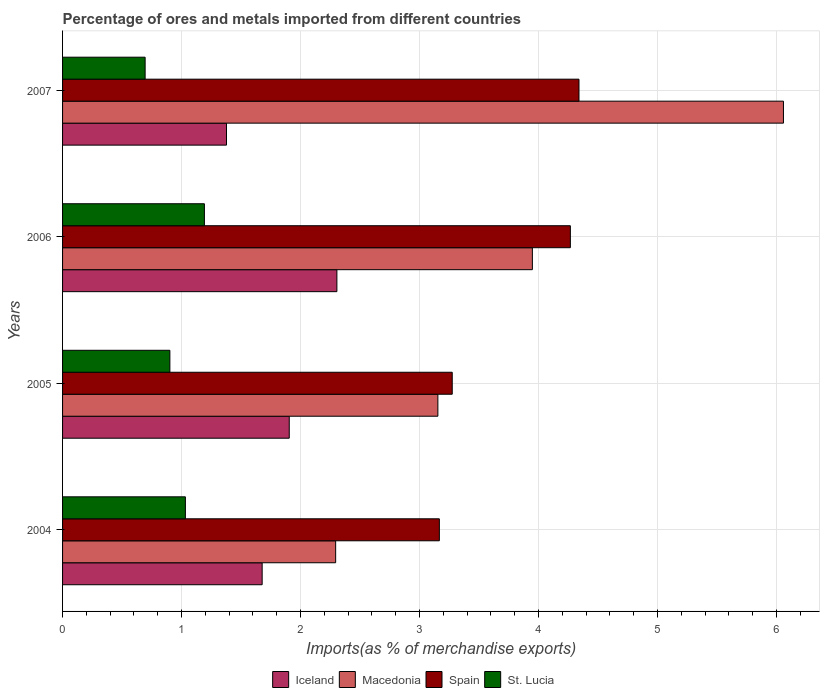How many different coloured bars are there?
Provide a short and direct response. 4. How many groups of bars are there?
Ensure brevity in your answer.  4. Are the number of bars per tick equal to the number of legend labels?
Provide a succinct answer. Yes. How many bars are there on the 2nd tick from the top?
Your response must be concise. 4. In how many cases, is the number of bars for a given year not equal to the number of legend labels?
Your answer should be very brief. 0. What is the percentage of imports to different countries in Macedonia in 2007?
Give a very brief answer. 6.06. Across all years, what is the maximum percentage of imports to different countries in St. Lucia?
Your answer should be very brief. 1.19. Across all years, what is the minimum percentage of imports to different countries in St. Lucia?
Your response must be concise. 0.69. In which year was the percentage of imports to different countries in Macedonia maximum?
Provide a succinct answer. 2007. What is the total percentage of imports to different countries in St. Lucia in the graph?
Provide a succinct answer. 3.82. What is the difference between the percentage of imports to different countries in St. Lucia in 2004 and that in 2006?
Provide a short and direct response. -0.16. What is the difference between the percentage of imports to different countries in Spain in 2004 and the percentage of imports to different countries in St. Lucia in 2006?
Your answer should be compact. 1.97. What is the average percentage of imports to different countries in Macedonia per year?
Offer a very short reply. 3.86. In the year 2004, what is the difference between the percentage of imports to different countries in Macedonia and percentage of imports to different countries in Iceland?
Offer a terse response. 0.62. What is the ratio of the percentage of imports to different countries in Macedonia in 2004 to that in 2005?
Your answer should be compact. 0.73. Is the percentage of imports to different countries in Iceland in 2004 less than that in 2005?
Your answer should be very brief. Yes. What is the difference between the highest and the second highest percentage of imports to different countries in Iceland?
Keep it short and to the point. 0.4. What is the difference between the highest and the lowest percentage of imports to different countries in Macedonia?
Offer a very short reply. 3.76. In how many years, is the percentage of imports to different countries in Iceland greater than the average percentage of imports to different countries in Iceland taken over all years?
Offer a very short reply. 2. Is the sum of the percentage of imports to different countries in Macedonia in 2005 and 2007 greater than the maximum percentage of imports to different countries in Spain across all years?
Ensure brevity in your answer.  Yes. What does the 3rd bar from the top in 2004 represents?
Give a very brief answer. Macedonia. Is it the case that in every year, the sum of the percentage of imports to different countries in Iceland and percentage of imports to different countries in Macedonia is greater than the percentage of imports to different countries in Spain?
Ensure brevity in your answer.  Yes. Are all the bars in the graph horizontal?
Your answer should be compact. Yes. Does the graph contain any zero values?
Provide a short and direct response. No. Does the graph contain grids?
Offer a very short reply. Yes. How many legend labels are there?
Keep it short and to the point. 4. What is the title of the graph?
Keep it short and to the point. Percentage of ores and metals imported from different countries. What is the label or title of the X-axis?
Give a very brief answer. Imports(as % of merchandise exports). What is the Imports(as % of merchandise exports) in Iceland in 2004?
Provide a succinct answer. 1.68. What is the Imports(as % of merchandise exports) in Macedonia in 2004?
Ensure brevity in your answer.  2.3. What is the Imports(as % of merchandise exports) in Spain in 2004?
Offer a terse response. 3.17. What is the Imports(as % of merchandise exports) of St. Lucia in 2004?
Provide a short and direct response. 1.03. What is the Imports(as % of merchandise exports) of Iceland in 2005?
Your answer should be compact. 1.91. What is the Imports(as % of merchandise exports) in Macedonia in 2005?
Offer a very short reply. 3.15. What is the Imports(as % of merchandise exports) of Spain in 2005?
Provide a short and direct response. 3.28. What is the Imports(as % of merchandise exports) of St. Lucia in 2005?
Your answer should be very brief. 0.9. What is the Imports(as % of merchandise exports) of Iceland in 2006?
Your answer should be compact. 2.31. What is the Imports(as % of merchandise exports) of Macedonia in 2006?
Provide a short and direct response. 3.95. What is the Imports(as % of merchandise exports) in Spain in 2006?
Give a very brief answer. 4.27. What is the Imports(as % of merchandise exports) of St. Lucia in 2006?
Give a very brief answer. 1.19. What is the Imports(as % of merchandise exports) in Iceland in 2007?
Your response must be concise. 1.38. What is the Imports(as % of merchandise exports) of Macedonia in 2007?
Offer a terse response. 6.06. What is the Imports(as % of merchandise exports) in Spain in 2007?
Your answer should be compact. 4.34. What is the Imports(as % of merchandise exports) of St. Lucia in 2007?
Provide a succinct answer. 0.69. Across all years, what is the maximum Imports(as % of merchandise exports) in Iceland?
Provide a short and direct response. 2.31. Across all years, what is the maximum Imports(as % of merchandise exports) of Macedonia?
Your response must be concise. 6.06. Across all years, what is the maximum Imports(as % of merchandise exports) of Spain?
Give a very brief answer. 4.34. Across all years, what is the maximum Imports(as % of merchandise exports) of St. Lucia?
Offer a terse response. 1.19. Across all years, what is the minimum Imports(as % of merchandise exports) of Iceland?
Keep it short and to the point. 1.38. Across all years, what is the minimum Imports(as % of merchandise exports) in Macedonia?
Your answer should be very brief. 2.3. Across all years, what is the minimum Imports(as % of merchandise exports) in Spain?
Your answer should be very brief. 3.17. Across all years, what is the minimum Imports(as % of merchandise exports) of St. Lucia?
Provide a short and direct response. 0.69. What is the total Imports(as % of merchandise exports) in Iceland in the graph?
Your answer should be very brief. 7.27. What is the total Imports(as % of merchandise exports) of Macedonia in the graph?
Offer a terse response. 15.46. What is the total Imports(as % of merchandise exports) in Spain in the graph?
Provide a succinct answer. 15.05. What is the total Imports(as % of merchandise exports) in St. Lucia in the graph?
Your answer should be very brief. 3.82. What is the difference between the Imports(as % of merchandise exports) in Iceland in 2004 and that in 2005?
Make the answer very short. -0.23. What is the difference between the Imports(as % of merchandise exports) of Macedonia in 2004 and that in 2005?
Make the answer very short. -0.86. What is the difference between the Imports(as % of merchandise exports) of Spain in 2004 and that in 2005?
Your answer should be very brief. -0.11. What is the difference between the Imports(as % of merchandise exports) in St. Lucia in 2004 and that in 2005?
Provide a short and direct response. 0.13. What is the difference between the Imports(as % of merchandise exports) in Iceland in 2004 and that in 2006?
Give a very brief answer. -0.63. What is the difference between the Imports(as % of merchandise exports) of Macedonia in 2004 and that in 2006?
Your answer should be very brief. -1.65. What is the difference between the Imports(as % of merchandise exports) in Spain in 2004 and that in 2006?
Your answer should be compact. -1.1. What is the difference between the Imports(as % of merchandise exports) of St. Lucia in 2004 and that in 2006?
Provide a succinct answer. -0.16. What is the difference between the Imports(as % of merchandise exports) of Iceland in 2004 and that in 2007?
Ensure brevity in your answer.  0.3. What is the difference between the Imports(as % of merchandise exports) in Macedonia in 2004 and that in 2007?
Offer a terse response. -3.76. What is the difference between the Imports(as % of merchandise exports) of Spain in 2004 and that in 2007?
Provide a succinct answer. -1.17. What is the difference between the Imports(as % of merchandise exports) in St. Lucia in 2004 and that in 2007?
Make the answer very short. 0.34. What is the difference between the Imports(as % of merchandise exports) in Iceland in 2005 and that in 2006?
Give a very brief answer. -0.4. What is the difference between the Imports(as % of merchandise exports) in Macedonia in 2005 and that in 2006?
Provide a short and direct response. -0.79. What is the difference between the Imports(as % of merchandise exports) of Spain in 2005 and that in 2006?
Your response must be concise. -0.99. What is the difference between the Imports(as % of merchandise exports) of St. Lucia in 2005 and that in 2006?
Keep it short and to the point. -0.29. What is the difference between the Imports(as % of merchandise exports) in Iceland in 2005 and that in 2007?
Offer a very short reply. 0.53. What is the difference between the Imports(as % of merchandise exports) in Macedonia in 2005 and that in 2007?
Keep it short and to the point. -2.9. What is the difference between the Imports(as % of merchandise exports) in Spain in 2005 and that in 2007?
Offer a very short reply. -1.07. What is the difference between the Imports(as % of merchandise exports) of St. Lucia in 2005 and that in 2007?
Provide a short and direct response. 0.21. What is the difference between the Imports(as % of merchandise exports) of Iceland in 2006 and that in 2007?
Provide a short and direct response. 0.93. What is the difference between the Imports(as % of merchandise exports) of Macedonia in 2006 and that in 2007?
Provide a succinct answer. -2.11. What is the difference between the Imports(as % of merchandise exports) of Spain in 2006 and that in 2007?
Give a very brief answer. -0.07. What is the difference between the Imports(as % of merchandise exports) in St. Lucia in 2006 and that in 2007?
Provide a short and direct response. 0.5. What is the difference between the Imports(as % of merchandise exports) in Iceland in 2004 and the Imports(as % of merchandise exports) in Macedonia in 2005?
Your response must be concise. -1.48. What is the difference between the Imports(as % of merchandise exports) in Iceland in 2004 and the Imports(as % of merchandise exports) in Spain in 2005?
Keep it short and to the point. -1.6. What is the difference between the Imports(as % of merchandise exports) in Iceland in 2004 and the Imports(as % of merchandise exports) in St. Lucia in 2005?
Keep it short and to the point. 0.78. What is the difference between the Imports(as % of merchandise exports) of Macedonia in 2004 and the Imports(as % of merchandise exports) of Spain in 2005?
Your response must be concise. -0.98. What is the difference between the Imports(as % of merchandise exports) of Macedonia in 2004 and the Imports(as % of merchandise exports) of St. Lucia in 2005?
Make the answer very short. 1.39. What is the difference between the Imports(as % of merchandise exports) in Spain in 2004 and the Imports(as % of merchandise exports) in St. Lucia in 2005?
Your answer should be compact. 2.27. What is the difference between the Imports(as % of merchandise exports) of Iceland in 2004 and the Imports(as % of merchandise exports) of Macedonia in 2006?
Offer a terse response. -2.27. What is the difference between the Imports(as % of merchandise exports) in Iceland in 2004 and the Imports(as % of merchandise exports) in Spain in 2006?
Ensure brevity in your answer.  -2.59. What is the difference between the Imports(as % of merchandise exports) in Iceland in 2004 and the Imports(as % of merchandise exports) in St. Lucia in 2006?
Offer a terse response. 0.49. What is the difference between the Imports(as % of merchandise exports) in Macedonia in 2004 and the Imports(as % of merchandise exports) in Spain in 2006?
Provide a short and direct response. -1.97. What is the difference between the Imports(as % of merchandise exports) in Macedonia in 2004 and the Imports(as % of merchandise exports) in St. Lucia in 2006?
Offer a terse response. 1.1. What is the difference between the Imports(as % of merchandise exports) of Spain in 2004 and the Imports(as % of merchandise exports) of St. Lucia in 2006?
Your answer should be very brief. 1.97. What is the difference between the Imports(as % of merchandise exports) in Iceland in 2004 and the Imports(as % of merchandise exports) in Macedonia in 2007?
Ensure brevity in your answer.  -4.38. What is the difference between the Imports(as % of merchandise exports) of Iceland in 2004 and the Imports(as % of merchandise exports) of Spain in 2007?
Ensure brevity in your answer.  -2.66. What is the difference between the Imports(as % of merchandise exports) of Iceland in 2004 and the Imports(as % of merchandise exports) of St. Lucia in 2007?
Give a very brief answer. 0.98. What is the difference between the Imports(as % of merchandise exports) in Macedonia in 2004 and the Imports(as % of merchandise exports) in Spain in 2007?
Offer a terse response. -2.05. What is the difference between the Imports(as % of merchandise exports) in Macedonia in 2004 and the Imports(as % of merchandise exports) in St. Lucia in 2007?
Make the answer very short. 1.6. What is the difference between the Imports(as % of merchandise exports) in Spain in 2004 and the Imports(as % of merchandise exports) in St. Lucia in 2007?
Your answer should be very brief. 2.47. What is the difference between the Imports(as % of merchandise exports) of Iceland in 2005 and the Imports(as % of merchandise exports) of Macedonia in 2006?
Give a very brief answer. -2.04. What is the difference between the Imports(as % of merchandise exports) in Iceland in 2005 and the Imports(as % of merchandise exports) in Spain in 2006?
Offer a terse response. -2.36. What is the difference between the Imports(as % of merchandise exports) of Iceland in 2005 and the Imports(as % of merchandise exports) of St. Lucia in 2006?
Offer a terse response. 0.71. What is the difference between the Imports(as % of merchandise exports) of Macedonia in 2005 and the Imports(as % of merchandise exports) of Spain in 2006?
Offer a terse response. -1.11. What is the difference between the Imports(as % of merchandise exports) of Macedonia in 2005 and the Imports(as % of merchandise exports) of St. Lucia in 2006?
Your answer should be very brief. 1.96. What is the difference between the Imports(as % of merchandise exports) of Spain in 2005 and the Imports(as % of merchandise exports) of St. Lucia in 2006?
Provide a succinct answer. 2.08. What is the difference between the Imports(as % of merchandise exports) in Iceland in 2005 and the Imports(as % of merchandise exports) in Macedonia in 2007?
Give a very brief answer. -4.15. What is the difference between the Imports(as % of merchandise exports) in Iceland in 2005 and the Imports(as % of merchandise exports) in Spain in 2007?
Your response must be concise. -2.44. What is the difference between the Imports(as % of merchandise exports) in Iceland in 2005 and the Imports(as % of merchandise exports) in St. Lucia in 2007?
Keep it short and to the point. 1.21. What is the difference between the Imports(as % of merchandise exports) in Macedonia in 2005 and the Imports(as % of merchandise exports) in Spain in 2007?
Offer a terse response. -1.19. What is the difference between the Imports(as % of merchandise exports) in Macedonia in 2005 and the Imports(as % of merchandise exports) in St. Lucia in 2007?
Your response must be concise. 2.46. What is the difference between the Imports(as % of merchandise exports) in Spain in 2005 and the Imports(as % of merchandise exports) in St. Lucia in 2007?
Provide a succinct answer. 2.58. What is the difference between the Imports(as % of merchandise exports) in Iceland in 2006 and the Imports(as % of merchandise exports) in Macedonia in 2007?
Your response must be concise. -3.75. What is the difference between the Imports(as % of merchandise exports) of Iceland in 2006 and the Imports(as % of merchandise exports) of Spain in 2007?
Give a very brief answer. -2.03. What is the difference between the Imports(as % of merchandise exports) of Iceland in 2006 and the Imports(as % of merchandise exports) of St. Lucia in 2007?
Make the answer very short. 1.61. What is the difference between the Imports(as % of merchandise exports) in Macedonia in 2006 and the Imports(as % of merchandise exports) in Spain in 2007?
Keep it short and to the point. -0.39. What is the difference between the Imports(as % of merchandise exports) of Macedonia in 2006 and the Imports(as % of merchandise exports) of St. Lucia in 2007?
Make the answer very short. 3.25. What is the difference between the Imports(as % of merchandise exports) in Spain in 2006 and the Imports(as % of merchandise exports) in St. Lucia in 2007?
Offer a very short reply. 3.57. What is the average Imports(as % of merchandise exports) in Iceland per year?
Provide a short and direct response. 1.82. What is the average Imports(as % of merchandise exports) of Macedonia per year?
Ensure brevity in your answer.  3.86. What is the average Imports(as % of merchandise exports) in Spain per year?
Provide a short and direct response. 3.76. What is the average Imports(as % of merchandise exports) in St. Lucia per year?
Provide a short and direct response. 0.96. In the year 2004, what is the difference between the Imports(as % of merchandise exports) of Iceland and Imports(as % of merchandise exports) of Macedonia?
Offer a terse response. -0.62. In the year 2004, what is the difference between the Imports(as % of merchandise exports) of Iceland and Imports(as % of merchandise exports) of Spain?
Your answer should be very brief. -1.49. In the year 2004, what is the difference between the Imports(as % of merchandise exports) in Iceland and Imports(as % of merchandise exports) in St. Lucia?
Keep it short and to the point. 0.65. In the year 2004, what is the difference between the Imports(as % of merchandise exports) of Macedonia and Imports(as % of merchandise exports) of Spain?
Make the answer very short. -0.87. In the year 2004, what is the difference between the Imports(as % of merchandise exports) in Macedonia and Imports(as % of merchandise exports) in St. Lucia?
Give a very brief answer. 1.26. In the year 2004, what is the difference between the Imports(as % of merchandise exports) in Spain and Imports(as % of merchandise exports) in St. Lucia?
Ensure brevity in your answer.  2.13. In the year 2005, what is the difference between the Imports(as % of merchandise exports) in Iceland and Imports(as % of merchandise exports) in Macedonia?
Your answer should be very brief. -1.25. In the year 2005, what is the difference between the Imports(as % of merchandise exports) in Iceland and Imports(as % of merchandise exports) in Spain?
Ensure brevity in your answer.  -1.37. In the year 2005, what is the difference between the Imports(as % of merchandise exports) in Iceland and Imports(as % of merchandise exports) in St. Lucia?
Provide a succinct answer. 1. In the year 2005, what is the difference between the Imports(as % of merchandise exports) in Macedonia and Imports(as % of merchandise exports) in Spain?
Your response must be concise. -0.12. In the year 2005, what is the difference between the Imports(as % of merchandise exports) of Macedonia and Imports(as % of merchandise exports) of St. Lucia?
Your answer should be compact. 2.25. In the year 2005, what is the difference between the Imports(as % of merchandise exports) in Spain and Imports(as % of merchandise exports) in St. Lucia?
Provide a short and direct response. 2.37. In the year 2006, what is the difference between the Imports(as % of merchandise exports) in Iceland and Imports(as % of merchandise exports) in Macedonia?
Provide a short and direct response. -1.64. In the year 2006, what is the difference between the Imports(as % of merchandise exports) of Iceland and Imports(as % of merchandise exports) of Spain?
Your answer should be very brief. -1.96. In the year 2006, what is the difference between the Imports(as % of merchandise exports) in Iceland and Imports(as % of merchandise exports) in St. Lucia?
Offer a terse response. 1.11. In the year 2006, what is the difference between the Imports(as % of merchandise exports) in Macedonia and Imports(as % of merchandise exports) in Spain?
Provide a short and direct response. -0.32. In the year 2006, what is the difference between the Imports(as % of merchandise exports) in Macedonia and Imports(as % of merchandise exports) in St. Lucia?
Provide a short and direct response. 2.76. In the year 2006, what is the difference between the Imports(as % of merchandise exports) of Spain and Imports(as % of merchandise exports) of St. Lucia?
Ensure brevity in your answer.  3.08. In the year 2007, what is the difference between the Imports(as % of merchandise exports) of Iceland and Imports(as % of merchandise exports) of Macedonia?
Offer a very short reply. -4.68. In the year 2007, what is the difference between the Imports(as % of merchandise exports) in Iceland and Imports(as % of merchandise exports) in Spain?
Offer a terse response. -2.96. In the year 2007, what is the difference between the Imports(as % of merchandise exports) of Iceland and Imports(as % of merchandise exports) of St. Lucia?
Offer a very short reply. 0.68. In the year 2007, what is the difference between the Imports(as % of merchandise exports) of Macedonia and Imports(as % of merchandise exports) of Spain?
Ensure brevity in your answer.  1.72. In the year 2007, what is the difference between the Imports(as % of merchandise exports) in Macedonia and Imports(as % of merchandise exports) in St. Lucia?
Provide a short and direct response. 5.37. In the year 2007, what is the difference between the Imports(as % of merchandise exports) in Spain and Imports(as % of merchandise exports) in St. Lucia?
Keep it short and to the point. 3.65. What is the ratio of the Imports(as % of merchandise exports) in Iceland in 2004 to that in 2005?
Offer a terse response. 0.88. What is the ratio of the Imports(as % of merchandise exports) of Macedonia in 2004 to that in 2005?
Your response must be concise. 0.73. What is the ratio of the Imports(as % of merchandise exports) in Spain in 2004 to that in 2005?
Offer a terse response. 0.97. What is the ratio of the Imports(as % of merchandise exports) in St. Lucia in 2004 to that in 2005?
Give a very brief answer. 1.14. What is the ratio of the Imports(as % of merchandise exports) in Iceland in 2004 to that in 2006?
Give a very brief answer. 0.73. What is the ratio of the Imports(as % of merchandise exports) of Macedonia in 2004 to that in 2006?
Ensure brevity in your answer.  0.58. What is the ratio of the Imports(as % of merchandise exports) in Spain in 2004 to that in 2006?
Give a very brief answer. 0.74. What is the ratio of the Imports(as % of merchandise exports) in St. Lucia in 2004 to that in 2006?
Offer a very short reply. 0.87. What is the ratio of the Imports(as % of merchandise exports) in Iceland in 2004 to that in 2007?
Keep it short and to the point. 1.22. What is the ratio of the Imports(as % of merchandise exports) of Macedonia in 2004 to that in 2007?
Your answer should be very brief. 0.38. What is the ratio of the Imports(as % of merchandise exports) in Spain in 2004 to that in 2007?
Provide a succinct answer. 0.73. What is the ratio of the Imports(as % of merchandise exports) of St. Lucia in 2004 to that in 2007?
Your answer should be compact. 1.49. What is the ratio of the Imports(as % of merchandise exports) in Iceland in 2005 to that in 2006?
Provide a short and direct response. 0.83. What is the ratio of the Imports(as % of merchandise exports) of Macedonia in 2005 to that in 2006?
Offer a very short reply. 0.8. What is the ratio of the Imports(as % of merchandise exports) of Spain in 2005 to that in 2006?
Ensure brevity in your answer.  0.77. What is the ratio of the Imports(as % of merchandise exports) in St. Lucia in 2005 to that in 2006?
Your answer should be very brief. 0.76. What is the ratio of the Imports(as % of merchandise exports) in Iceland in 2005 to that in 2007?
Your answer should be very brief. 1.38. What is the ratio of the Imports(as % of merchandise exports) of Macedonia in 2005 to that in 2007?
Your answer should be compact. 0.52. What is the ratio of the Imports(as % of merchandise exports) in Spain in 2005 to that in 2007?
Make the answer very short. 0.75. What is the ratio of the Imports(as % of merchandise exports) of St. Lucia in 2005 to that in 2007?
Ensure brevity in your answer.  1.3. What is the ratio of the Imports(as % of merchandise exports) in Iceland in 2006 to that in 2007?
Give a very brief answer. 1.67. What is the ratio of the Imports(as % of merchandise exports) in Macedonia in 2006 to that in 2007?
Give a very brief answer. 0.65. What is the ratio of the Imports(as % of merchandise exports) of Spain in 2006 to that in 2007?
Your answer should be compact. 0.98. What is the ratio of the Imports(as % of merchandise exports) of St. Lucia in 2006 to that in 2007?
Ensure brevity in your answer.  1.72. What is the difference between the highest and the second highest Imports(as % of merchandise exports) of Iceland?
Make the answer very short. 0.4. What is the difference between the highest and the second highest Imports(as % of merchandise exports) of Macedonia?
Your answer should be compact. 2.11. What is the difference between the highest and the second highest Imports(as % of merchandise exports) in Spain?
Ensure brevity in your answer.  0.07. What is the difference between the highest and the second highest Imports(as % of merchandise exports) in St. Lucia?
Offer a very short reply. 0.16. What is the difference between the highest and the lowest Imports(as % of merchandise exports) in Iceland?
Provide a short and direct response. 0.93. What is the difference between the highest and the lowest Imports(as % of merchandise exports) of Macedonia?
Provide a succinct answer. 3.76. What is the difference between the highest and the lowest Imports(as % of merchandise exports) of Spain?
Provide a succinct answer. 1.17. What is the difference between the highest and the lowest Imports(as % of merchandise exports) in St. Lucia?
Make the answer very short. 0.5. 